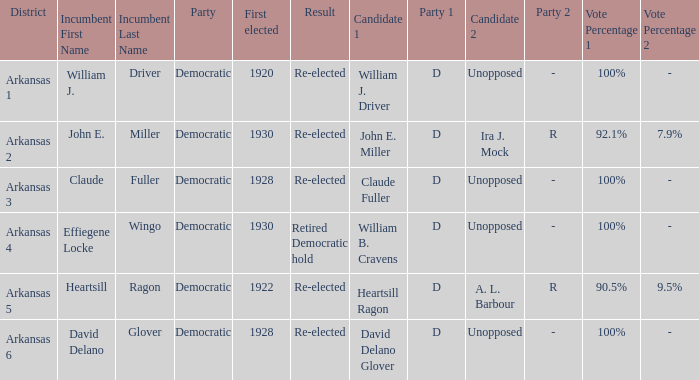In how many districts was the incumbent David Delano Glover?  1.0. 